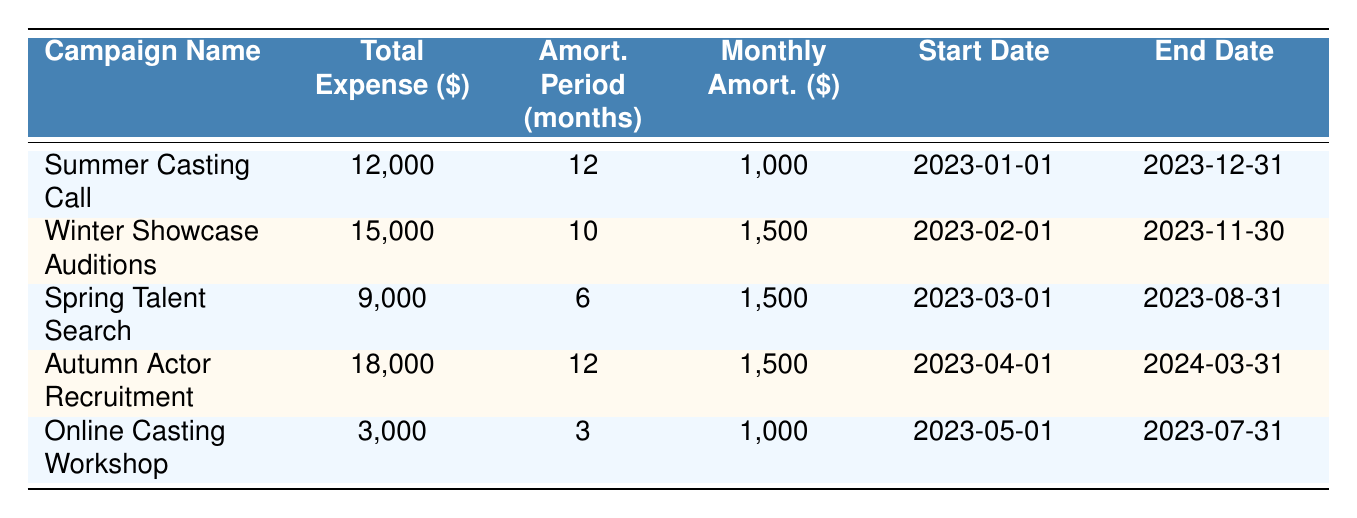What is the total expense for the "Summer Casting Call"? The table states that the total expense for the "Summer Casting Call" is 12,000.
Answer: 12,000 How many months is the amortization period for the "Winter Showcase Auditions"? As per the table, the amortization period for the "Winter Showcase Auditions" is 10 months.
Answer: 10 months Is the monthly amortization for the "Online Casting Workshop" 1,000? The table indicates that the monthly amortization for the "Online Casting Workshop" is, indeed, 1,000.
Answer: Yes What is the campaign with the highest total expense? By examining the total expenses in the table, "Autumn Actor Recruitment" has the highest total expense at 18,000.
Answer: Autumn Actor Recruitment How many total expenses are over 10,000? There are 4 campaign expenses over 10,000: "Summer Casting Call" (12,000), "Winter Showcase Auditions" (15,000), "Autumn Actor Recruitment" (18,000). The "Spring Talent Search" is the only one below 10,000, thus counting only 4.
Answer: 4 What was the average monthly amortization across all campaigns? The total monthly amortization values are: 1,000 (Summer Casting Call) + 1,500 (Winter Showcase Auditions) + 1,500 (Spring Talent Search) + 1,500 (Autumn Actor Recruitment) + 1,000 (Online Casting Workshop) = 6,500. There are 5 campaigns, so the average is 6,500 / 5 = 1,300.
Answer: 1,300 Does the "Spring Talent Search" campaign end before the "Autumn Actor Recruitment" campaign? The "Spring Talent Search" ends on 2023-08-31 while the "Autumn Actor Recruitment" ends on 2024-03-31, so the statement is true.
Answer: Yes How much total expense is related to campaigns that have an amortization period of 12 months? The campaigns with a 12-month period are "Summer Casting Call" (12,000) and "Autumn Actor Recruitment" (18,000). The total expense for these campaigns is 12,000 + 18,000 = 30,000.
Answer: 30,000 What is the difference in total expenses between the "Spring Talent Search" and the "Winter Showcase Auditions"? The total expense for the "Winter Showcase Auditions" is 15,000, and for the "Spring Talent Search," it is 9,000. The difference is calculated as 15,000 - 9,000 = 6,000.
Answer: 6,000 